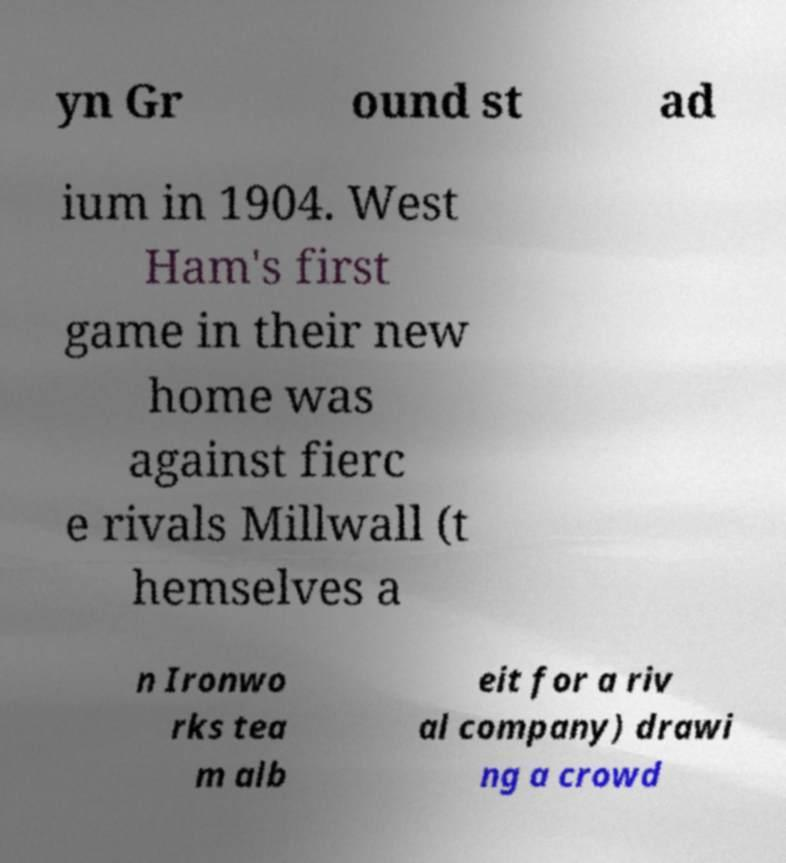Could you assist in decoding the text presented in this image and type it out clearly? yn Gr ound st ad ium in 1904. West Ham's first game in their new home was against fierc e rivals Millwall (t hemselves a n Ironwo rks tea m alb eit for a riv al company) drawi ng a crowd 